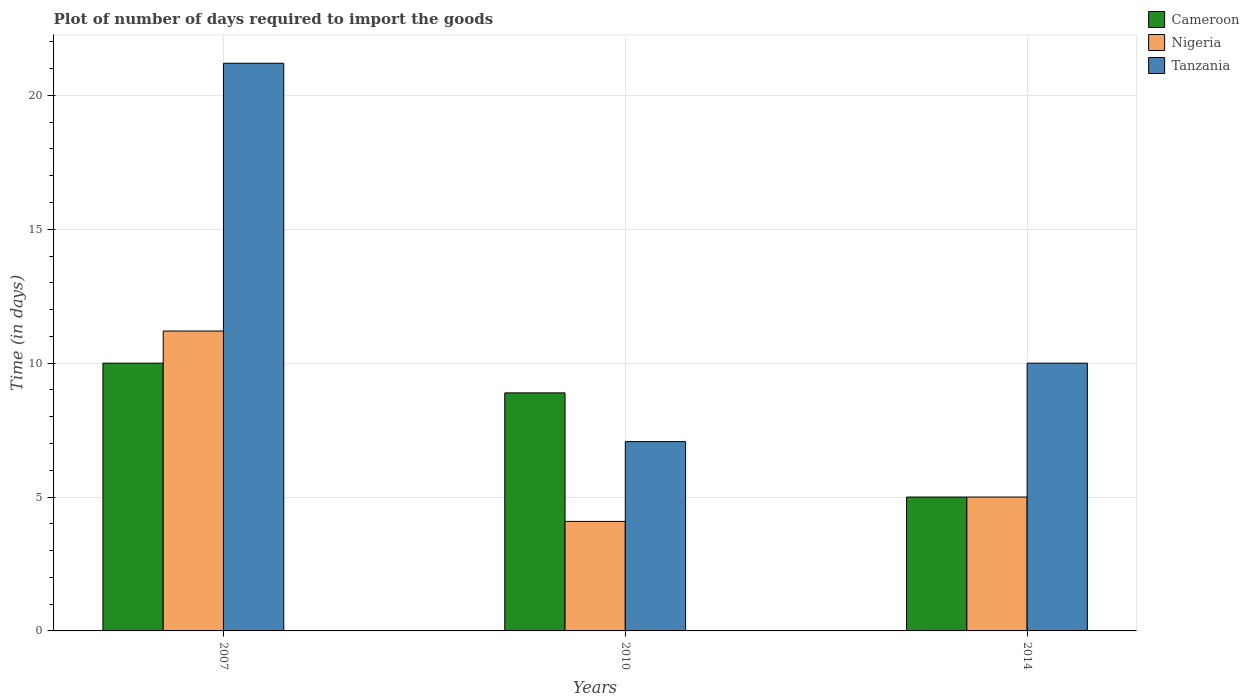How many groups of bars are there?
Provide a short and direct response. 3. Are the number of bars per tick equal to the number of legend labels?
Make the answer very short. Yes. Are the number of bars on each tick of the X-axis equal?
Keep it short and to the point. Yes. How many bars are there on the 2nd tick from the right?
Keep it short and to the point. 3. In how many cases, is the number of bars for a given year not equal to the number of legend labels?
Your answer should be compact. 0. What is the time required to import goods in Cameroon in 2010?
Your answer should be compact. 8.89. Across all years, what is the minimum time required to import goods in Tanzania?
Your answer should be very brief. 7.07. What is the total time required to import goods in Tanzania in the graph?
Provide a short and direct response. 38.27. What is the difference between the time required to import goods in Nigeria in 2010 and that in 2014?
Ensure brevity in your answer.  -0.91. What is the average time required to import goods in Cameroon per year?
Your answer should be compact. 7.96. What is the ratio of the time required to import goods in Nigeria in 2010 to that in 2014?
Give a very brief answer. 0.82. Is the time required to import goods in Nigeria in 2007 less than that in 2010?
Your answer should be compact. No. What is the difference between the highest and the second highest time required to import goods in Nigeria?
Give a very brief answer. 6.2. What does the 3rd bar from the left in 2010 represents?
Ensure brevity in your answer.  Tanzania. What does the 3rd bar from the right in 2010 represents?
Provide a short and direct response. Cameroon. Is it the case that in every year, the sum of the time required to import goods in Cameroon and time required to import goods in Tanzania is greater than the time required to import goods in Nigeria?
Offer a terse response. Yes. How many bars are there?
Your answer should be very brief. 9. Are all the bars in the graph horizontal?
Offer a very short reply. No. How many years are there in the graph?
Keep it short and to the point. 3. What is the difference between two consecutive major ticks on the Y-axis?
Keep it short and to the point. 5. Does the graph contain any zero values?
Give a very brief answer. No. Does the graph contain grids?
Give a very brief answer. Yes. How many legend labels are there?
Give a very brief answer. 3. How are the legend labels stacked?
Offer a very short reply. Vertical. What is the title of the graph?
Give a very brief answer. Plot of number of days required to import the goods. Does "Cuba" appear as one of the legend labels in the graph?
Ensure brevity in your answer.  No. What is the label or title of the Y-axis?
Make the answer very short. Time (in days). What is the Time (in days) in Cameroon in 2007?
Your response must be concise. 10. What is the Time (in days) in Tanzania in 2007?
Offer a very short reply. 21.2. What is the Time (in days) in Cameroon in 2010?
Your response must be concise. 8.89. What is the Time (in days) of Nigeria in 2010?
Provide a short and direct response. 4.09. What is the Time (in days) of Tanzania in 2010?
Provide a short and direct response. 7.07. What is the Time (in days) of Cameroon in 2014?
Make the answer very short. 5. What is the Time (in days) in Nigeria in 2014?
Provide a short and direct response. 5. Across all years, what is the maximum Time (in days) of Nigeria?
Offer a very short reply. 11.2. Across all years, what is the maximum Time (in days) in Tanzania?
Give a very brief answer. 21.2. Across all years, what is the minimum Time (in days) of Nigeria?
Give a very brief answer. 4.09. Across all years, what is the minimum Time (in days) of Tanzania?
Give a very brief answer. 7.07. What is the total Time (in days) in Cameroon in the graph?
Your response must be concise. 23.89. What is the total Time (in days) in Nigeria in the graph?
Give a very brief answer. 20.29. What is the total Time (in days) in Tanzania in the graph?
Your answer should be compact. 38.27. What is the difference between the Time (in days) of Cameroon in 2007 and that in 2010?
Give a very brief answer. 1.11. What is the difference between the Time (in days) of Nigeria in 2007 and that in 2010?
Keep it short and to the point. 7.11. What is the difference between the Time (in days) in Tanzania in 2007 and that in 2010?
Your answer should be compact. 14.13. What is the difference between the Time (in days) of Nigeria in 2007 and that in 2014?
Your answer should be compact. 6.2. What is the difference between the Time (in days) in Cameroon in 2010 and that in 2014?
Ensure brevity in your answer.  3.89. What is the difference between the Time (in days) of Nigeria in 2010 and that in 2014?
Offer a terse response. -0.91. What is the difference between the Time (in days) of Tanzania in 2010 and that in 2014?
Offer a very short reply. -2.93. What is the difference between the Time (in days) in Cameroon in 2007 and the Time (in days) in Nigeria in 2010?
Provide a short and direct response. 5.91. What is the difference between the Time (in days) in Cameroon in 2007 and the Time (in days) in Tanzania in 2010?
Offer a very short reply. 2.93. What is the difference between the Time (in days) in Nigeria in 2007 and the Time (in days) in Tanzania in 2010?
Offer a very short reply. 4.13. What is the difference between the Time (in days) in Cameroon in 2007 and the Time (in days) in Nigeria in 2014?
Your answer should be compact. 5. What is the difference between the Time (in days) in Cameroon in 2007 and the Time (in days) in Tanzania in 2014?
Offer a terse response. 0. What is the difference between the Time (in days) in Nigeria in 2007 and the Time (in days) in Tanzania in 2014?
Keep it short and to the point. 1.2. What is the difference between the Time (in days) of Cameroon in 2010 and the Time (in days) of Nigeria in 2014?
Make the answer very short. 3.89. What is the difference between the Time (in days) of Cameroon in 2010 and the Time (in days) of Tanzania in 2014?
Offer a terse response. -1.11. What is the difference between the Time (in days) of Nigeria in 2010 and the Time (in days) of Tanzania in 2014?
Provide a short and direct response. -5.91. What is the average Time (in days) in Cameroon per year?
Your answer should be compact. 7.96. What is the average Time (in days) of Nigeria per year?
Make the answer very short. 6.76. What is the average Time (in days) of Tanzania per year?
Offer a terse response. 12.76. In the year 2007, what is the difference between the Time (in days) in Cameroon and Time (in days) in Nigeria?
Offer a terse response. -1.2. In the year 2007, what is the difference between the Time (in days) in Nigeria and Time (in days) in Tanzania?
Offer a very short reply. -10. In the year 2010, what is the difference between the Time (in days) of Cameroon and Time (in days) of Nigeria?
Make the answer very short. 4.8. In the year 2010, what is the difference between the Time (in days) of Cameroon and Time (in days) of Tanzania?
Your answer should be compact. 1.82. In the year 2010, what is the difference between the Time (in days) of Nigeria and Time (in days) of Tanzania?
Give a very brief answer. -2.98. In the year 2014, what is the difference between the Time (in days) in Nigeria and Time (in days) in Tanzania?
Make the answer very short. -5. What is the ratio of the Time (in days) of Cameroon in 2007 to that in 2010?
Your response must be concise. 1.12. What is the ratio of the Time (in days) in Nigeria in 2007 to that in 2010?
Give a very brief answer. 2.74. What is the ratio of the Time (in days) of Tanzania in 2007 to that in 2010?
Make the answer very short. 3. What is the ratio of the Time (in days) in Nigeria in 2007 to that in 2014?
Ensure brevity in your answer.  2.24. What is the ratio of the Time (in days) in Tanzania in 2007 to that in 2014?
Provide a short and direct response. 2.12. What is the ratio of the Time (in days) in Cameroon in 2010 to that in 2014?
Your response must be concise. 1.78. What is the ratio of the Time (in days) in Nigeria in 2010 to that in 2014?
Keep it short and to the point. 0.82. What is the ratio of the Time (in days) in Tanzania in 2010 to that in 2014?
Offer a terse response. 0.71. What is the difference between the highest and the second highest Time (in days) of Cameroon?
Provide a succinct answer. 1.11. What is the difference between the highest and the second highest Time (in days) in Nigeria?
Offer a terse response. 6.2. What is the difference between the highest and the lowest Time (in days) in Cameroon?
Ensure brevity in your answer.  5. What is the difference between the highest and the lowest Time (in days) in Nigeria?
Your response must be concise. 7.11. What is the difference between the highest and the lowest Time (in days) in Tanzania?
Your answer should be compact. 14.13. 